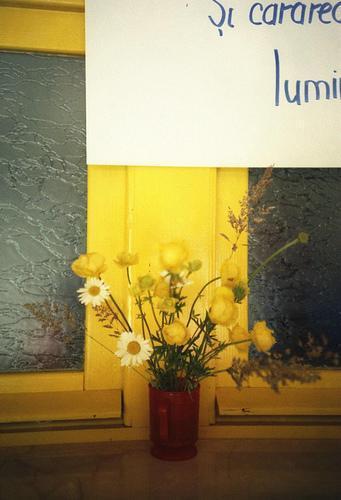How many windows are shown?
Give a very brief answer. 2. 